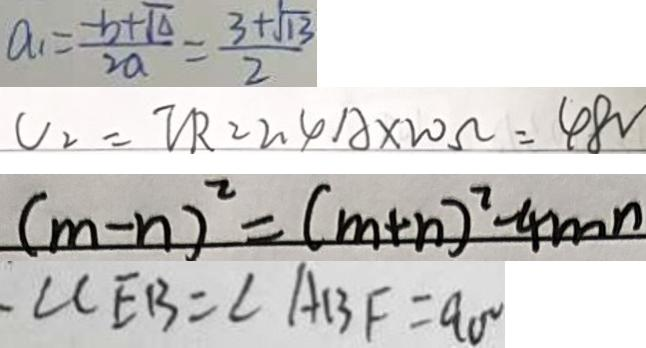<formula> <loc_0><loc_0><loc_500><loc_500>a _ { 1 } = \frac { - b + \sqrt { \Delta } } { 2 a } = \frac { 3 + \sqrt { 1 3 } } { 2 } 
 V _ { 2 } = V R = 2 . 4 A \times 2 0 \Omega = 4 8 V 
 ( m - n ) ^ { 2 } = ( m + n ) ^ { 2 } - 4 m n 
 \angle C E B = \angle A B F = 9 0 ^ { \circ }</formula> 